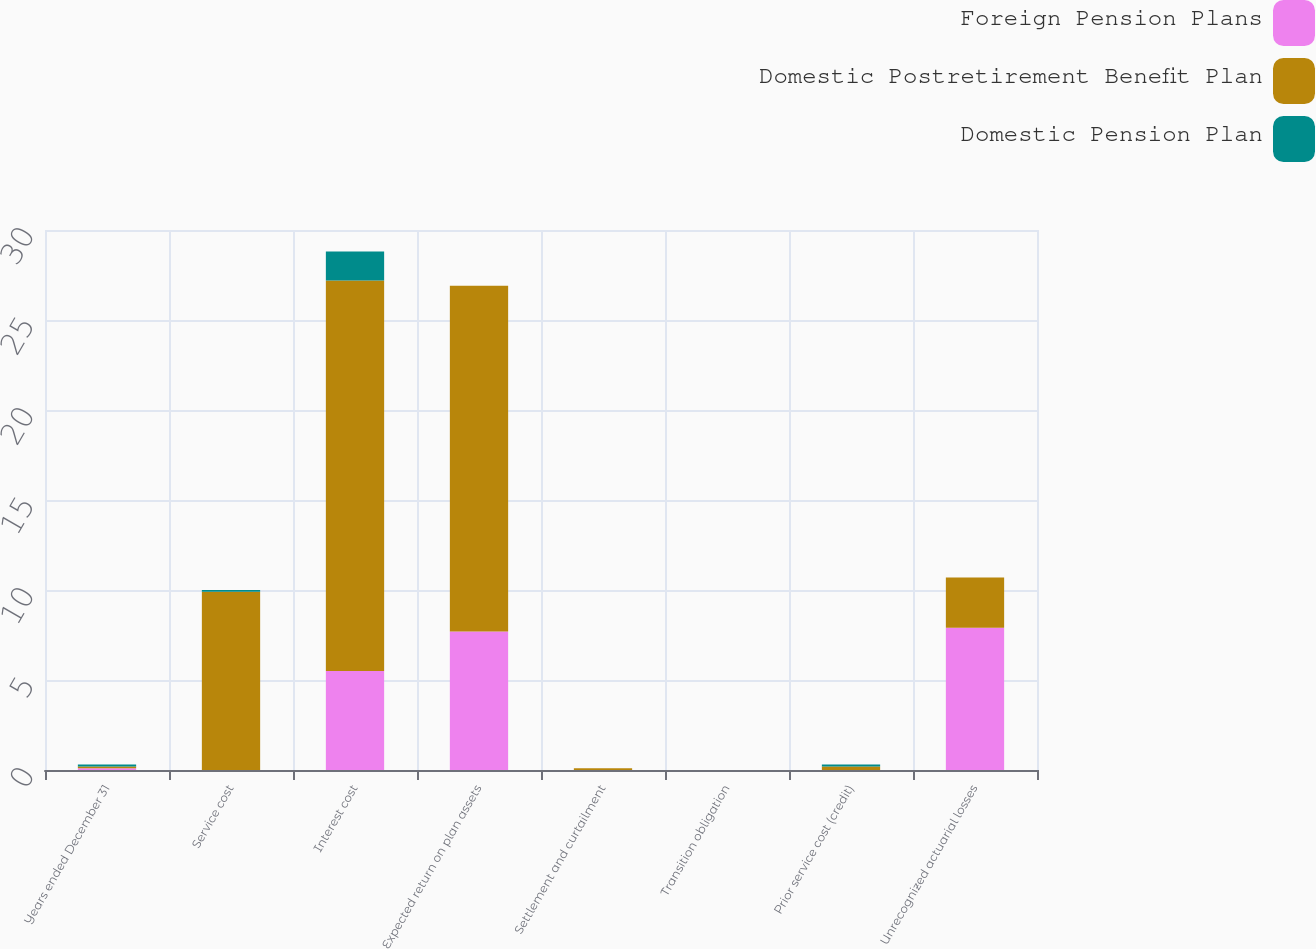Convert chart. <chart><loc_0><loc_0><loc_500><loc_500><stacked_bar_chart><ecel><fcel>Years ended December 31<fcel>Service cost<fcel>Interest cost<fcel>Expected return on plan assets<fcel>Settlement and curtailment<fcel>Transition obligation<fcel>Prior service cost (credit)<fcel>Unrecognized actuarial losses<nl><fcel>Foreign Pension Plans<fcel>0.1<fcel>0<fcel>5.5<fcel>7.7<fcel>0<fcel>0<fcel>0<fcel>7.9<nl><fcel>Domestic Postretirement Benefit Plan<fcel>0.1<fcel>9.9<fcel>21.7<fcel>19.2<fcel>0.1<fcel>0<fcel>0.2<fcel>2.8<nl><fcel>Domestic Pension Plan<fcel>0.1<fcel>0.1<fcel>1.6<fcel>0<fcel>0<fcel>0<fcel>0.1<fcel>0<nl></chart> 